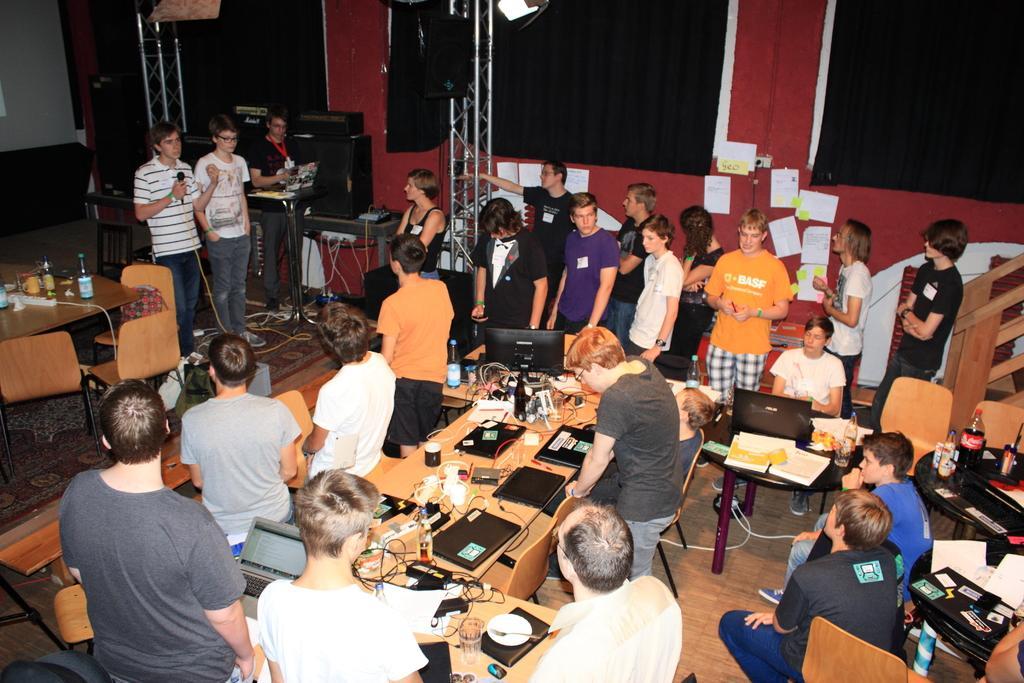Please provide a concise description of this image. In this image we can see some persons standing and some are sitting, we can see some laptops, wires, glasses and some other items on table, on left side of the image we can see three persons standing and playing musical instruments and in the background of the image there are some sound boxes and there is a wall. 